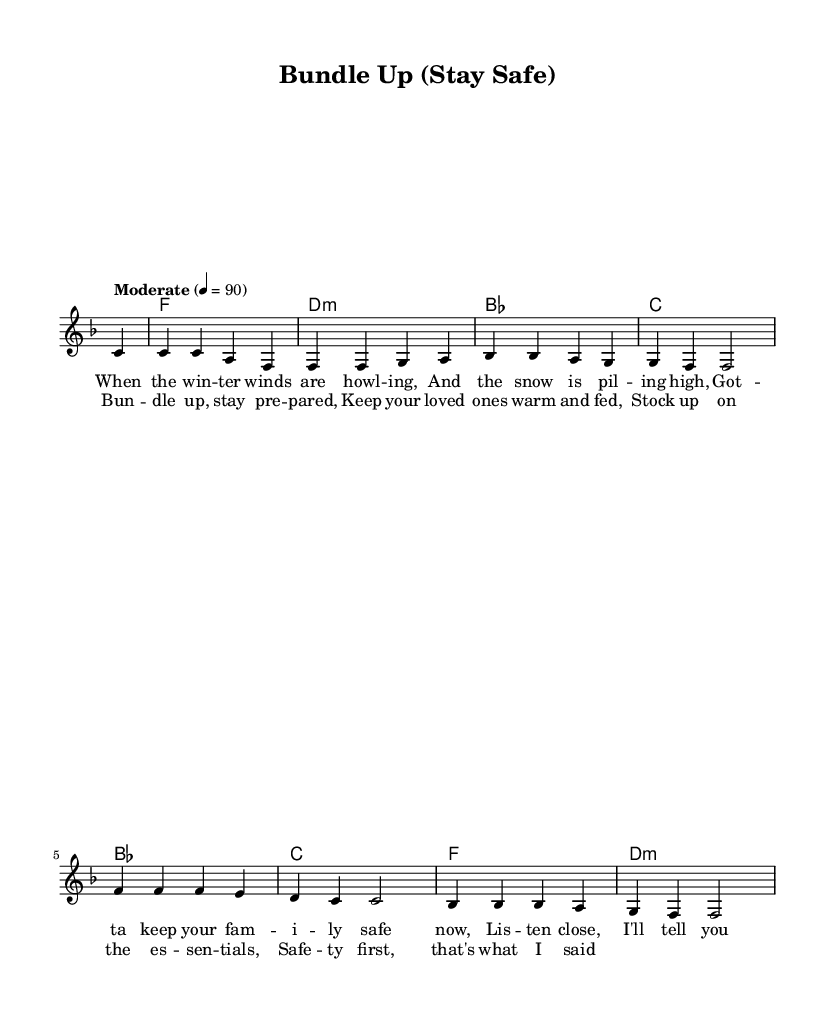What is the key signature of this music? The key signature is F major, indicated by one flat (B). You can identify the key signature by looking at the beginning of the staff where it shows the number of sharps or flats.
Answer: F major What is the time signature of this piece? The time signature is 4/4, which can be found at the beginning of the staff next to the clef. It indicates that there are four beats in each measure and the quarter note receives one beat.
Answer: 4/4 What is the tempo marking for this music? The tempo marking is "Moderate," with a metronome marking of 90 beats per minute. This can be interpreted from the tempo indication given at the beginning of the score, which describes how fast the piece should be played.
Answer: Moderate How many measures are in the melody section? The melody section consists of eight measures. You can count the vertical lines (bar lines) in the melody part to find the number of measures. Each bar line represents the end of a measure.
Answer: Eight What is the first lyric line of the chorus? The first lyric line of the chorus is "Bun -- dle up, stay pre -- pared." You can find the lyrics written directly beneath the melody notes, aligned with each corresponding note.
Answer: Bun -- dle up, stay pre -- pared What is the primary theme expressed in the lyrics? The primary theme expressed in the lyrics emphasizes safety and preparedness during winter. This can be inferred from lines that discuss gathering essentials and keeping loved ones warm, which focus on safety measures in harsher weather conditions.
Answer: Safety and preparedness Is there a specific chord progression that defines this R&B piece? Yes, the chord progression follows a sequence of F, D minor, B flat, and C chords. Observing the harmony section reveals the chord progression written above the melody, which typically enhances the emotional feel common in R&B.
Answer: F, D minor, B flat, C 